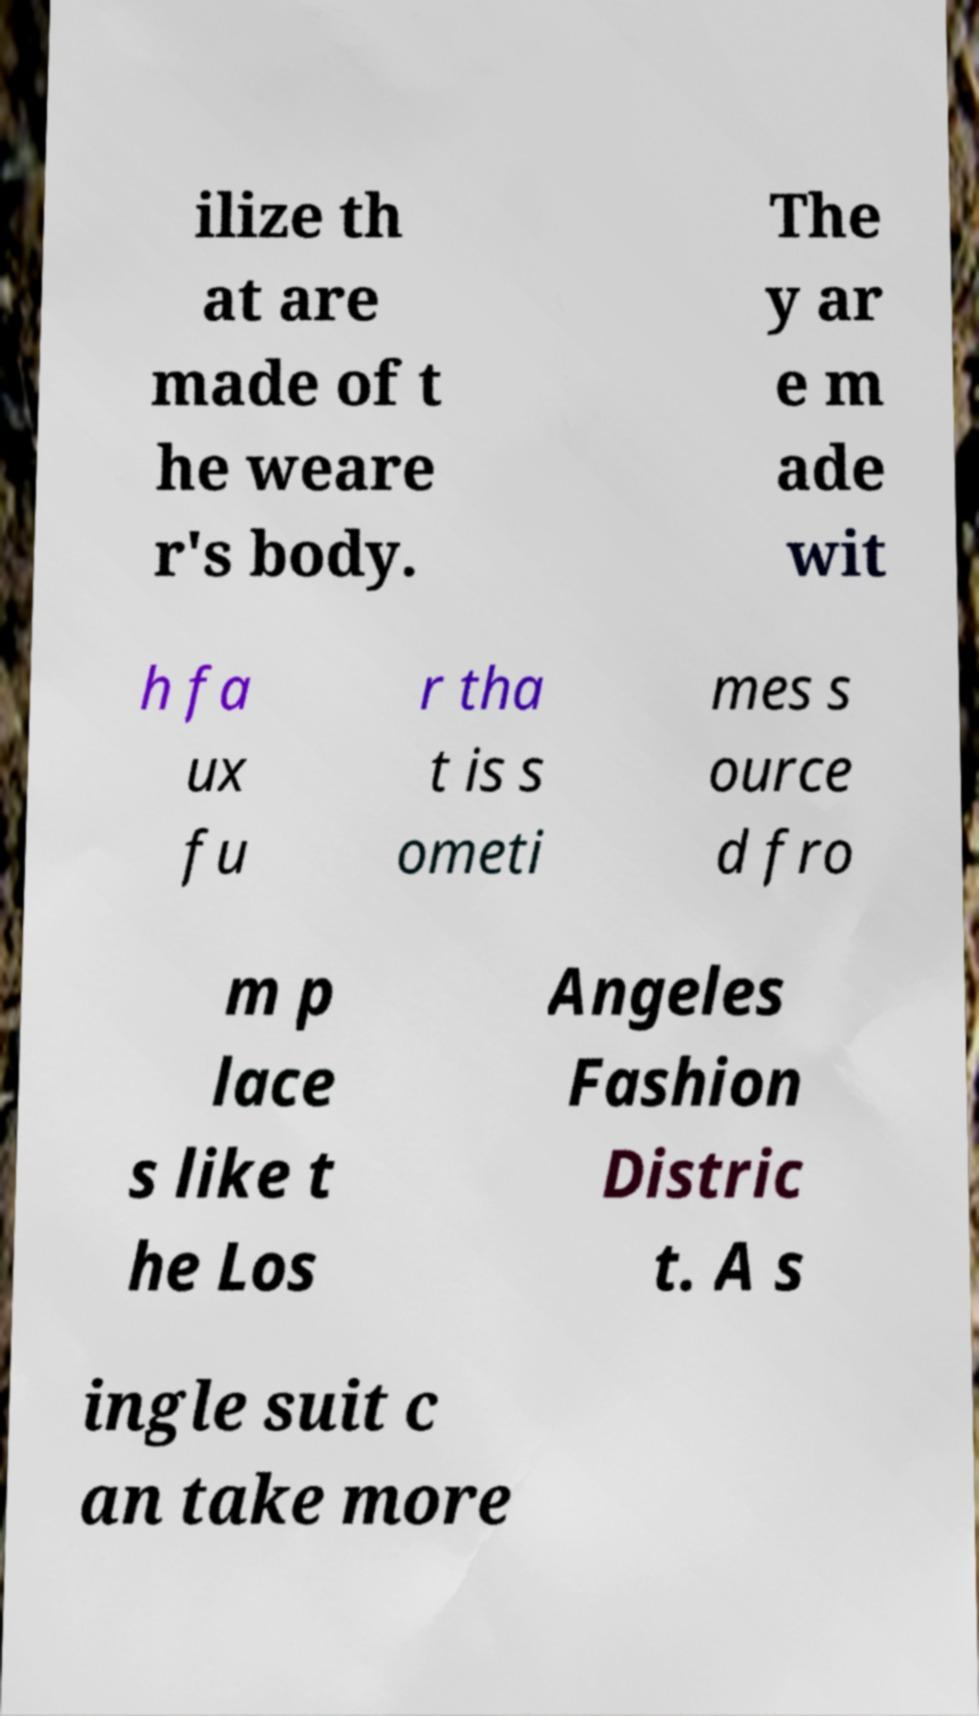There's text embedded in this image that I need extracted. Can you transcribe it verbatim? ilize th at are made of t he weare r's body. The y ar e m ade wit h fa ux fu r tha t is s ometi mes s ource d fro m p lace s like t he Los Angeles Fashion Distric t. A s ingle suit c an take more 